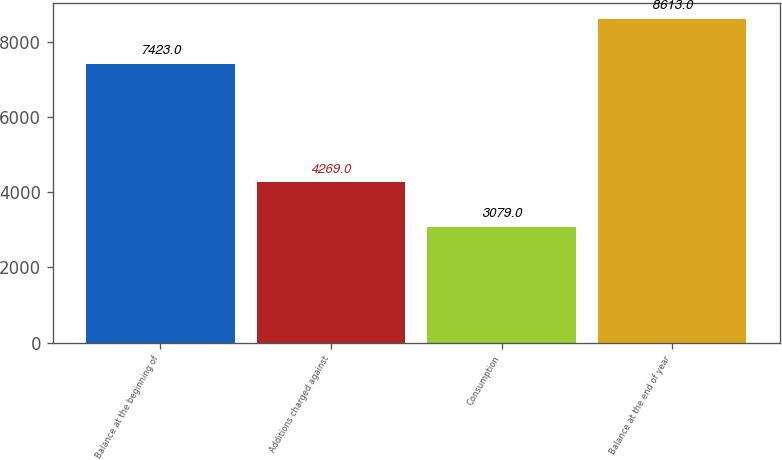Convert chart to OTSL. <chart><loc_0><loc_0><loc_500><loc_500><bar_chart><fcel>Balance at the beginning of<fcel>Additions charged against<fcel>Consumption<fcel>Balance at the end of year<nl><fcel>7423<fcel>4269<fcel>3079<fcel>8613<nl></chart> 